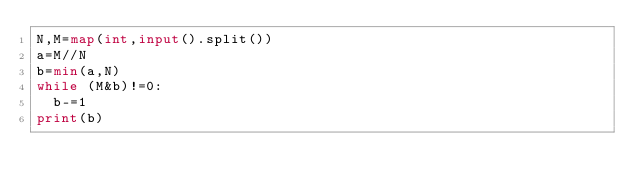<code> <loc_0><loc_0><loc_500><loc_500><_Python_>N,M=map(int,input().split())
a=M//N
b=min(a,N)
while (M&b)!=0:
  b-=1
print(b)</code> 